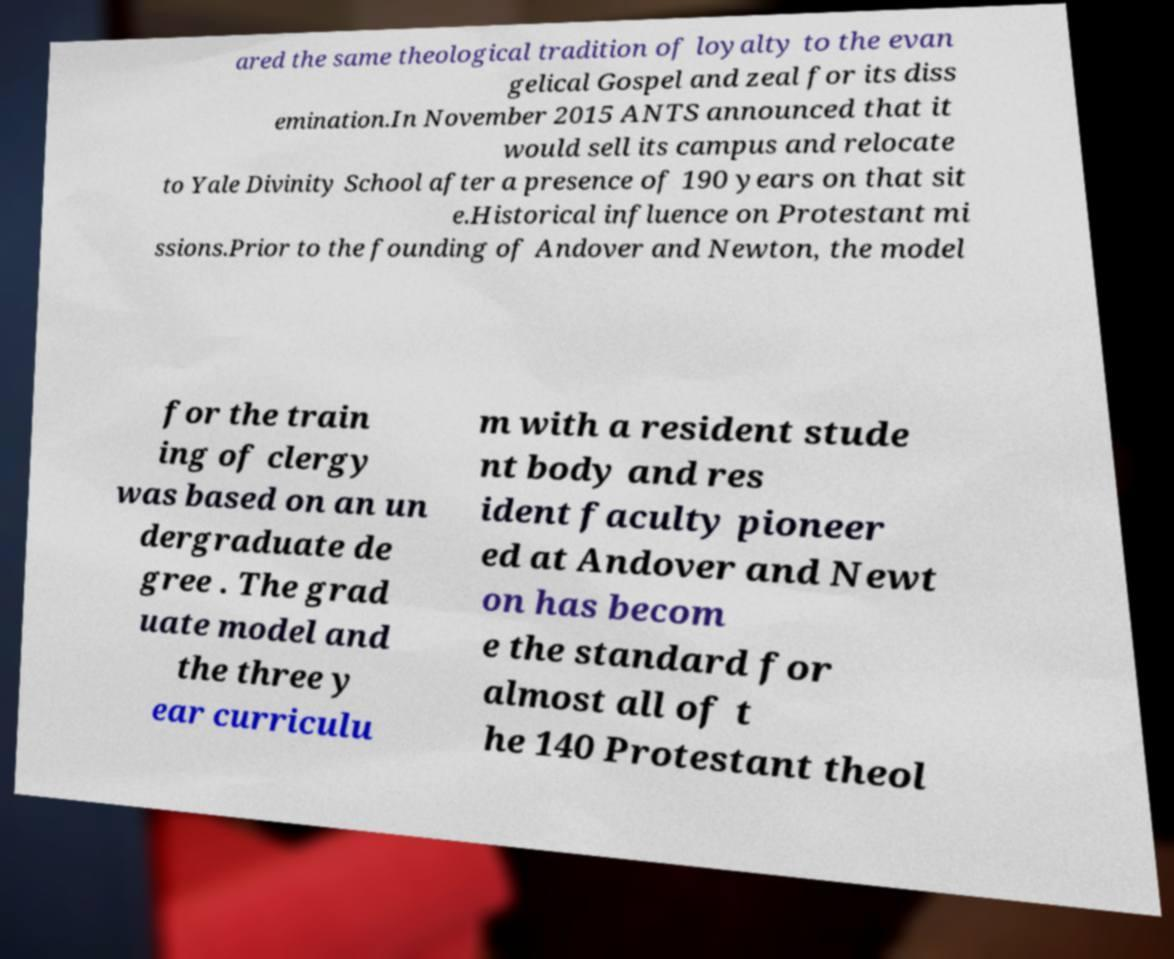Could you extract and type out the text from this image? ared the same theological tradition of loyalty to the evan gelical Gospel and zeal for its diss emination.In November 2015 ANTS announced that it would sell its campus and relocate to Yale Divinity School after a presence of 190 years on that sit e.Historical influence on Protestant mi ssions.Prior to the founding of Andover and Newton, the model for the train ing of clergy was based on an un dergraduate de gree . The grad uate model and the three y ear curriculu m with a resident stude nt body and res ident faculty pioneer ed at Andover and Newt on has becom e the standard for almost all of t he 140 Protestant theol 